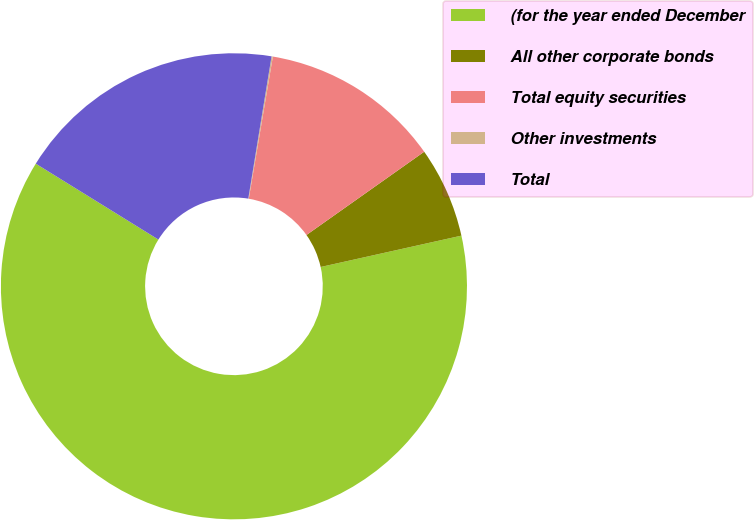<chart> <loc_0><loc_0><loc_500><loc_500><pie_chart><fcel>(for the year ended December<fcel>All other corporate bonds<fcel>Total equity securities<fcel>Other investments<fcel>Total<nl><fcel>62.3%<fcel>6.31%<fcel>12.53%<fcel>0.09%<fcel>18.76%<nl></chart> 